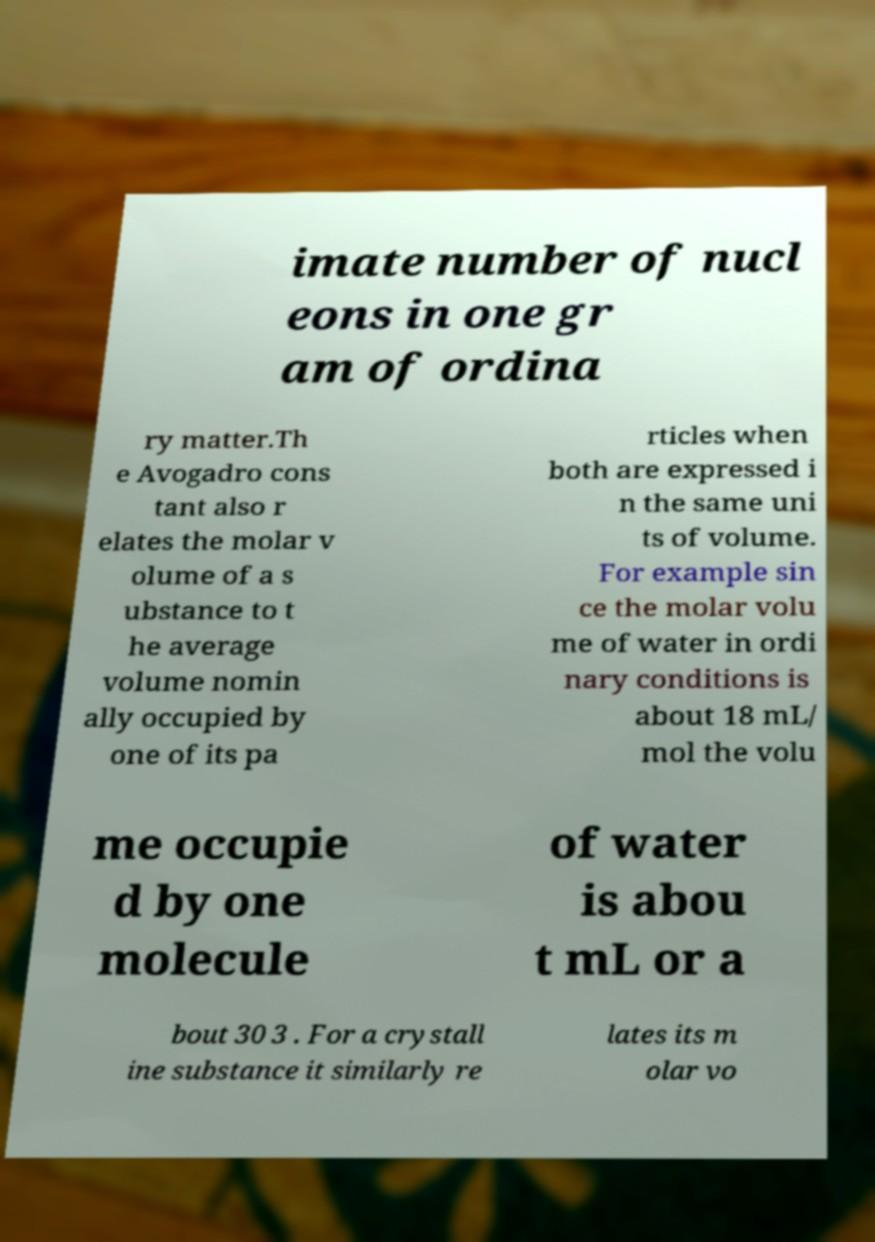Could you extract and type out the text from this image? imate number of nucl eons in one gr am of ordina ry matter.Th e Avogadro cons tant also r elates the molar v olume of a s ubstance to t he average volume nomin ally occupied by one of its pa rticles when both are expressed i n the same uni ts of volume. For example sin ce the molar volu me of water in ordi nary conditions is about 18 mL/ mol the volu me occupie d by one molecule of water is abou t mL or a bout 30 3 . For a crystall ine substance it similarly re lates its m olar vo 